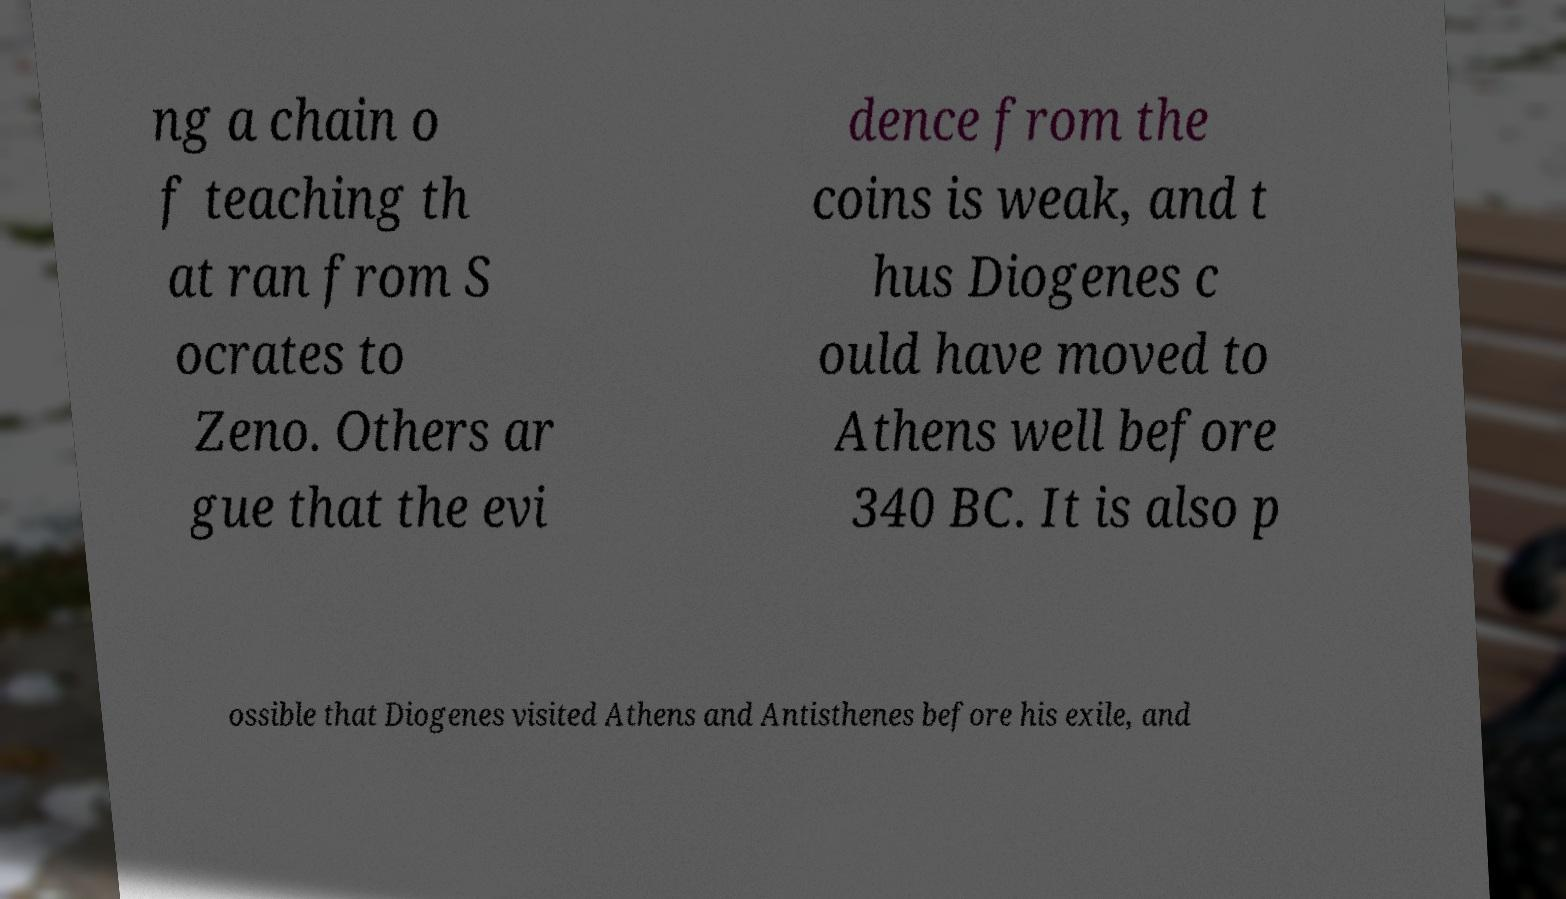Could you assist in decoding the text presented in this image and type it out clearly? ng a chain o f teaching th at ran from S ocrates to Zeno. Others ar gue that the evi dence from the coins is weak, and t hus Diogenes c ould have moved to Athens well before 340 BC. It is also p ossible that Diogenes visited Athens and Antisthenes before his exile, and 